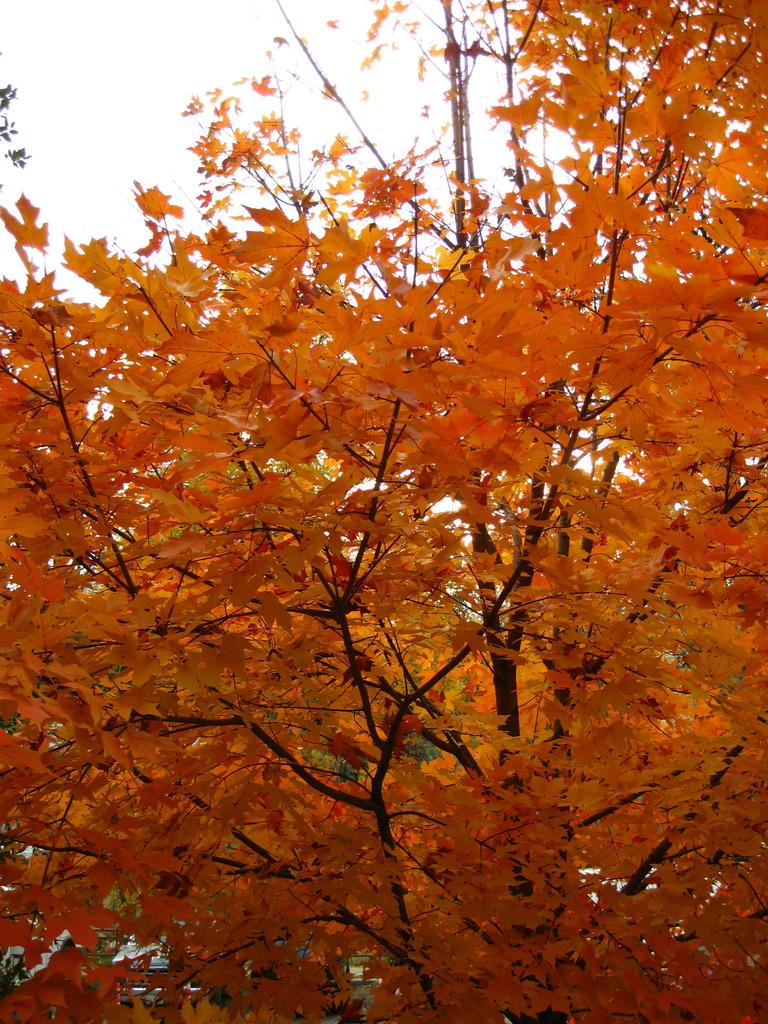What type of vegetation can be seen in the image? There are trees in the image. What is the color of the leaves on the trees? The leaves of the trees are orange in color. What type of cup is being used to express hate in the image? There is no cup or expression of hate present in the image; it only features trees with orange leaves. 